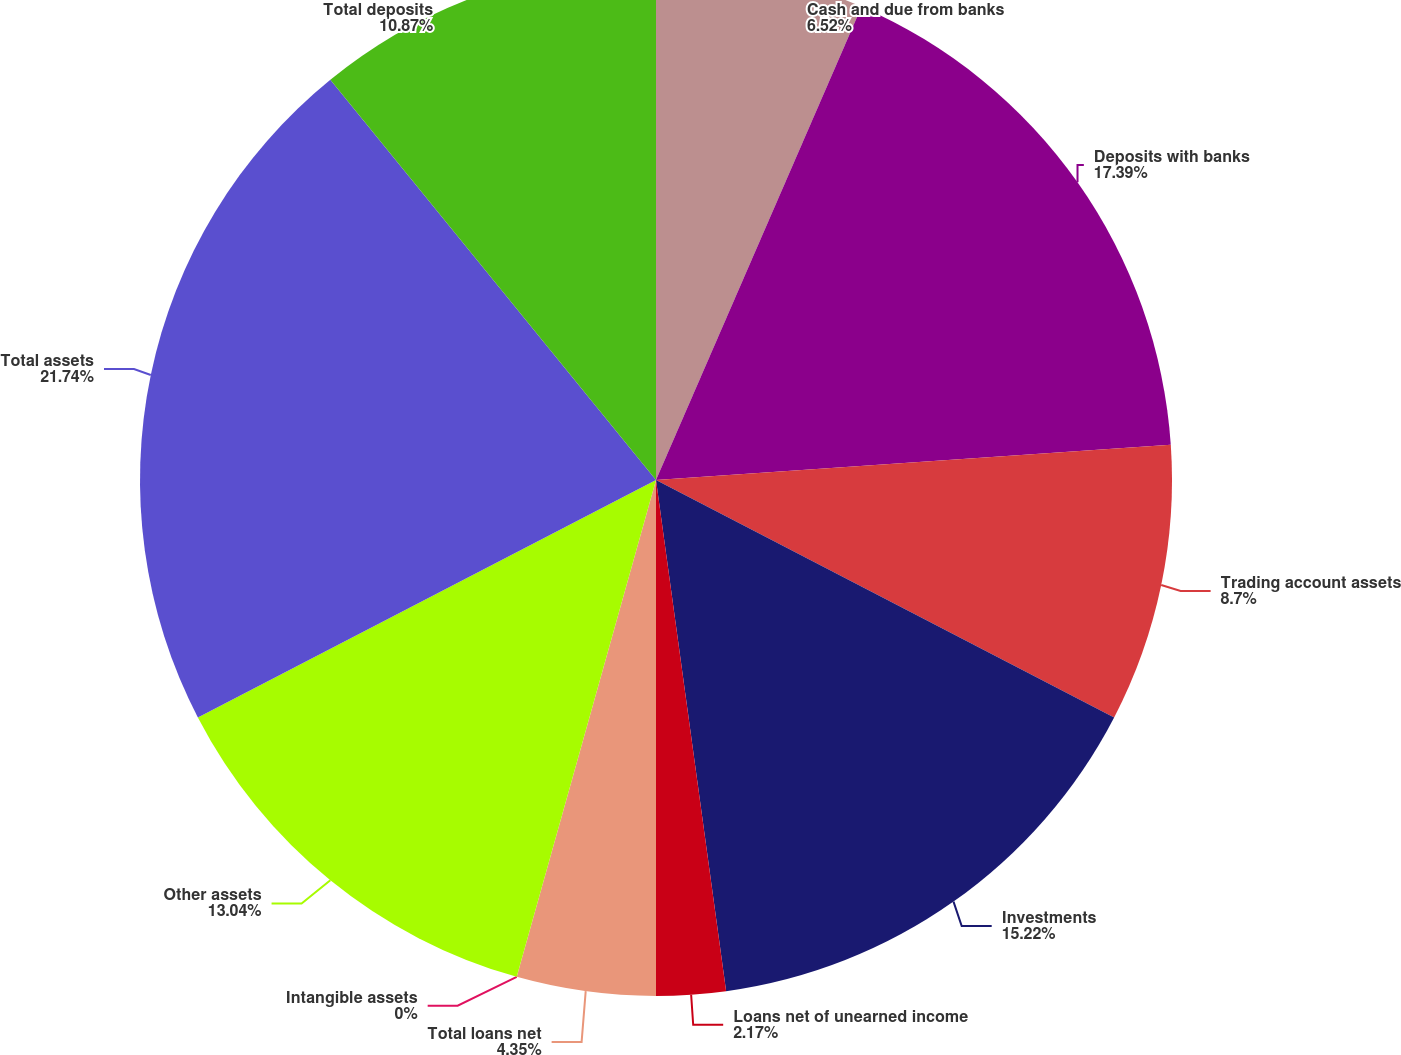Convert chart. <chart><loc_0><loc_0><loc_500><loc_500><pie_chart><fcel>Cash and due from banks<fcel>Deposits with banks<fcel>Trading account assets<fcel>Investments<fcel>Loans net of unearned income<fcel>Total loans net<fcel>Intangible assets<fcel>Other assets<fcel>Total assets<fcel>Total deposits<nl><fcel>6.52%<fcel>17.39%<fcel>8.7%<fcel>15.22%<fcel>2.17%<fcel>4.35%<fcel>0.0%<fcel>13.04%<fcel>21.74%<fcel>10.87%<nl></chart> 